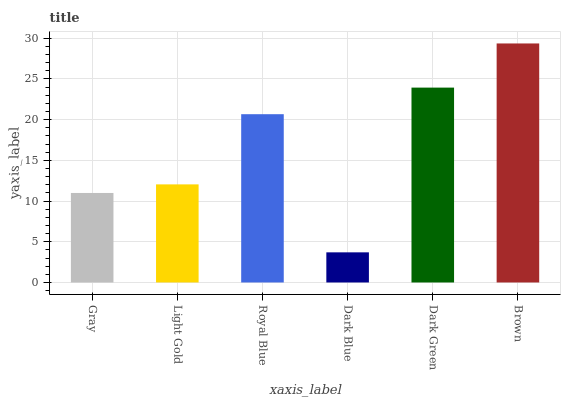Is Light Gold the minimum?
Answer yes or no. No. Is Light Gold the maximum?
Answer yes or no. No. Is Light Gold greater than Gray?
Answer yes or no. Yes. Is Gray less than Light Gold?
Answer yes or no. Yes. Is Gray greater than Light Gold?
Answer yes or no. No. Is Light Gold less than Gray?
Answer yes or no. No. Is Royal Blue the high median?
Answer yes or no. Yes. Is Light Gold the low median?
Answer yes or no. Yes. Is Gray the high median?
Answer yes or no. No. Is Dark Green the low median?
Answer yes or no. No. 